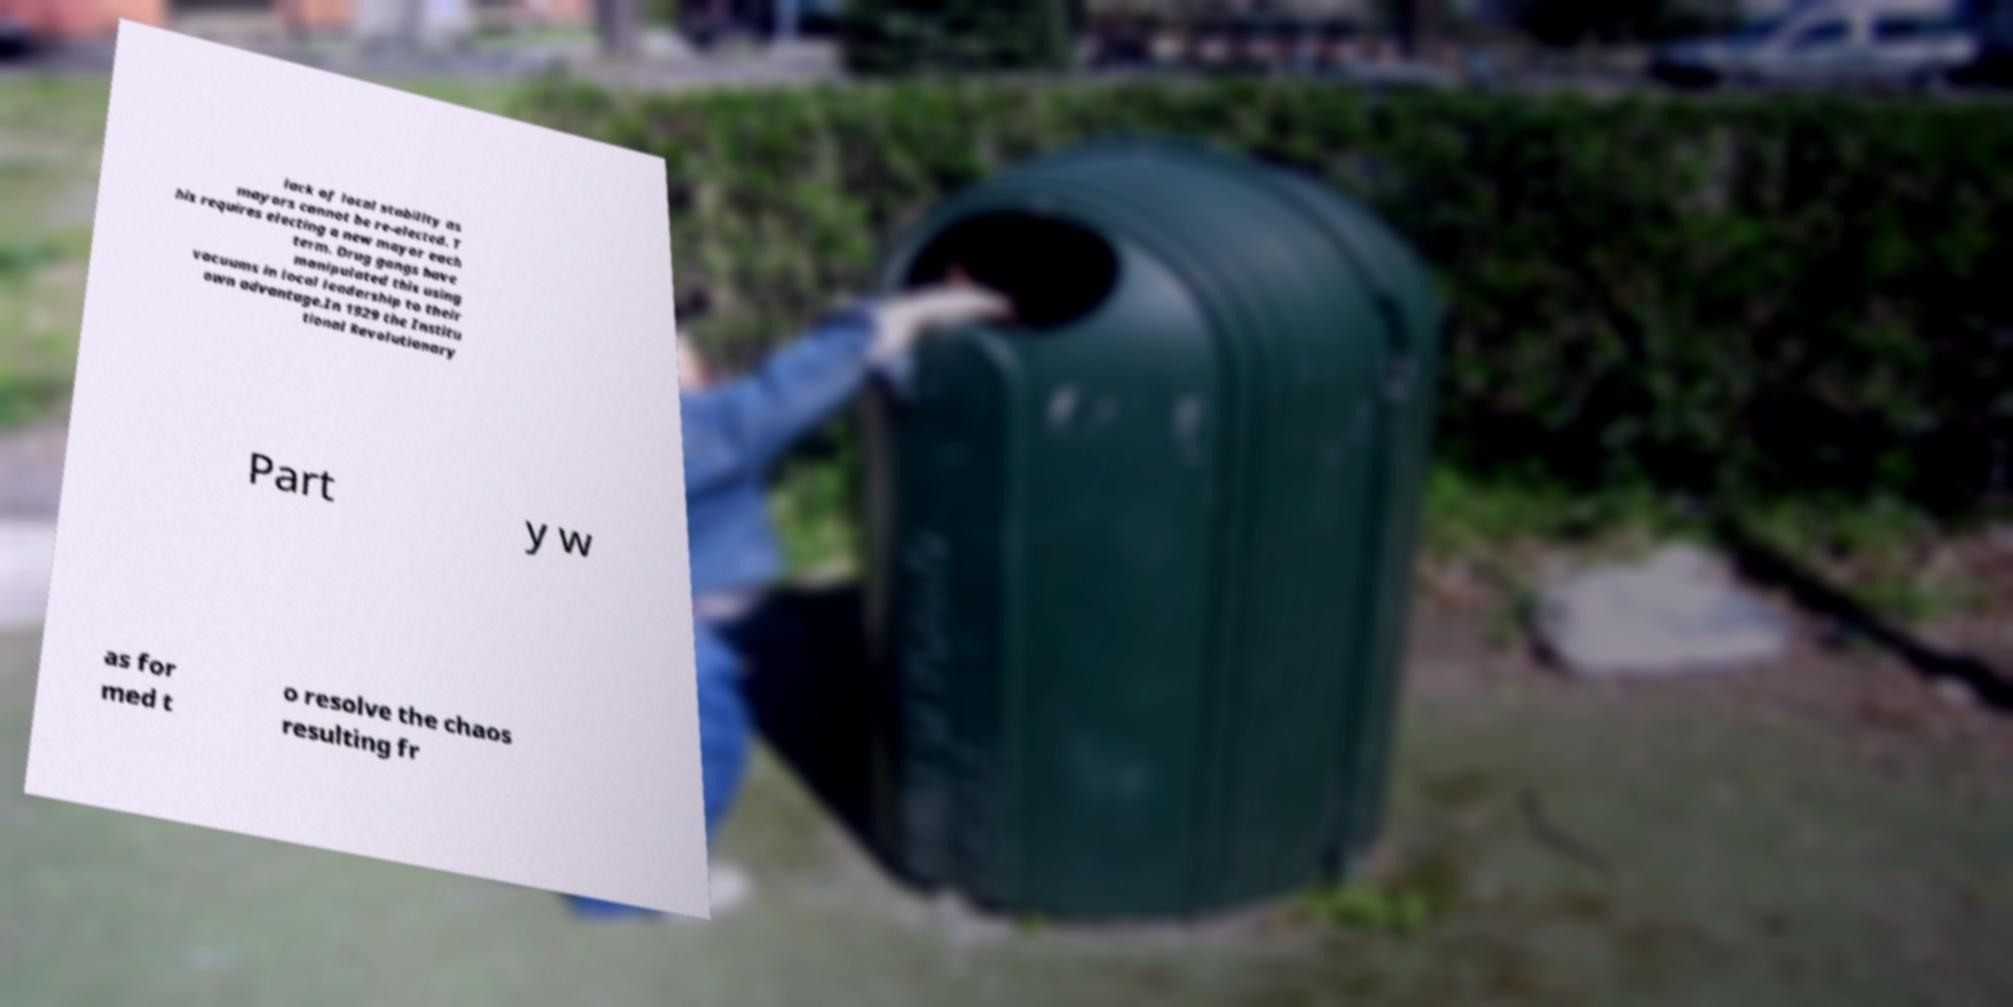Please read and relay the text visible in this image. What does it say? lack of local stability as mayors cannot be re-elected. T his requires electing a new mayor each term. Drug gangs have manipulated this using vacuums in local leadership to their own advantage.In 1929 the Institu tional Revolutionary Part y w as for med t o resolve the chaos resulting fr 